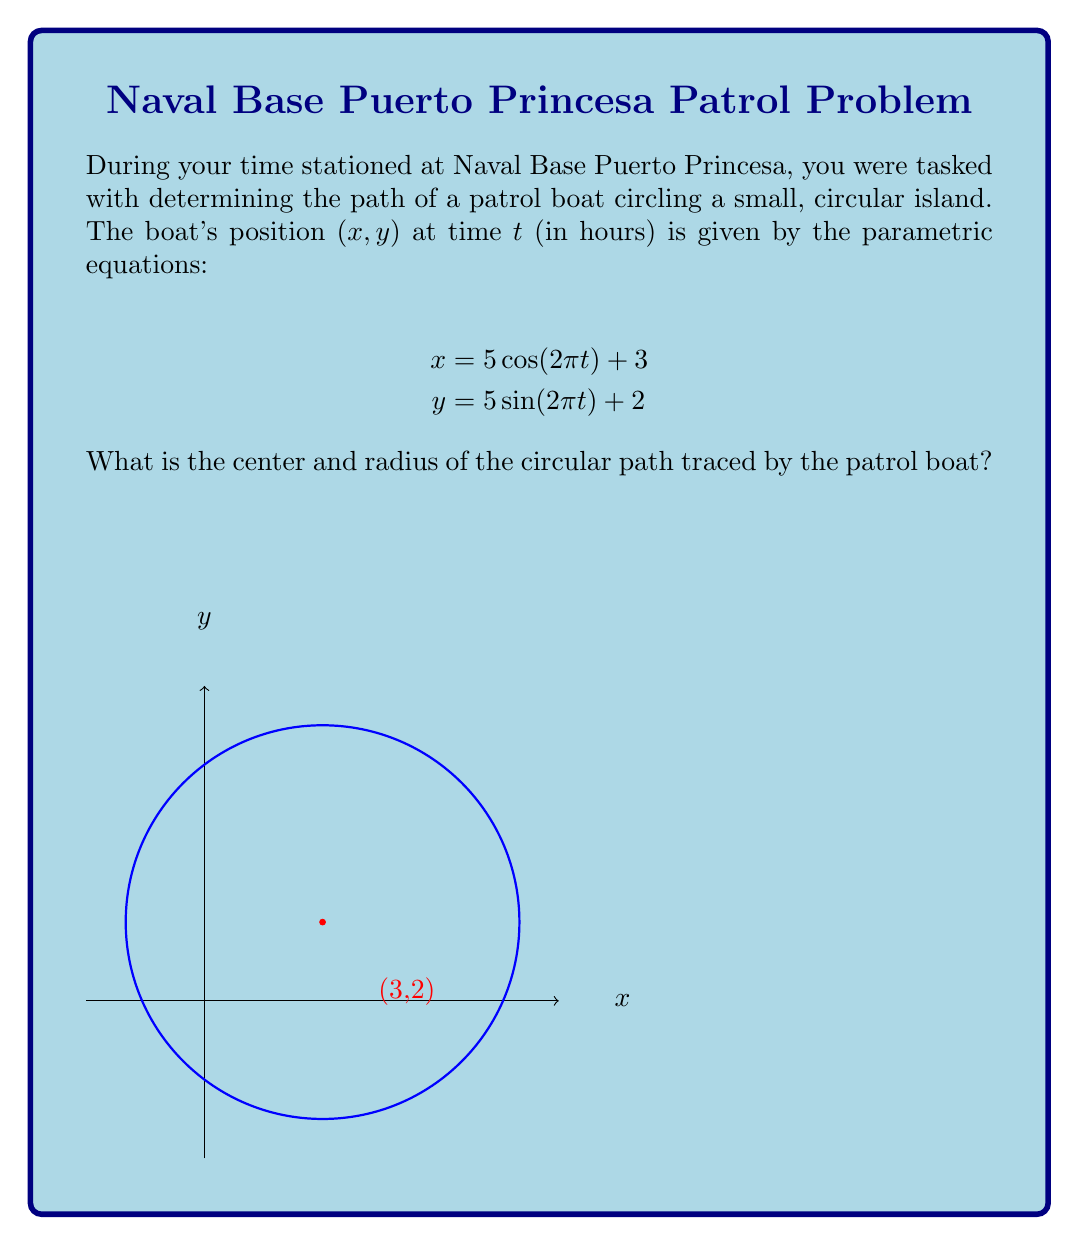Can you answer this question? Let's approach this step-by-step:

1) The general form of parametric equations for a circle is:
   $$x = r\cos(2\pi t) + h$$
   $$y = r\sin(2\pi t) + k$$
   where $(h,k)$ is the center and $r$ is the radius.

2) Comparing our given equations to this general form:
   $$x = 5\cos(2\pi t) + 3$$
   $$y = 5\sin(2\pi t) + 2$$

3) We can identify that:
   - The coefficient of $\cos(2\pi t)$ and $\sin(2\pi t)$ is 5, so $r = 5$.
   - The constant term in the $x$ equation is 3, so $h = 3$.
   - The constant term in the $y$ equation is 2, so $k = 2$.

4) Therefore, the center of the circle is at $(h,k) = (3,2)$.

5) The radius of the circle is $r = 5$.
Answer: Center: $(3,2)$, Radius: $5$ 